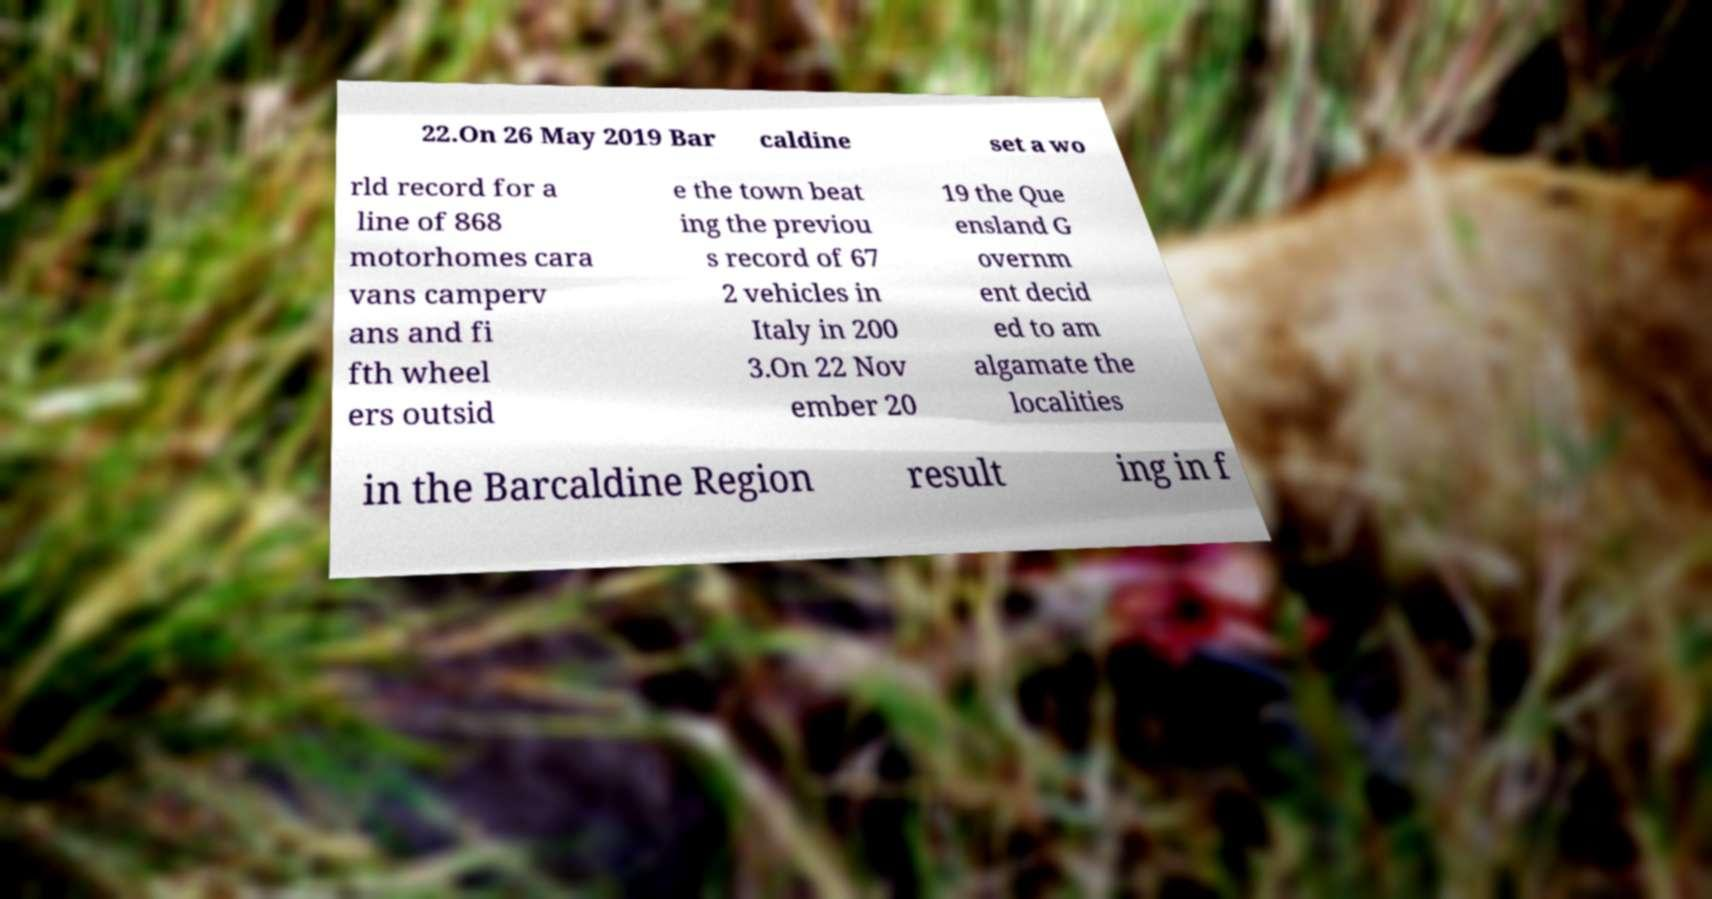Please read and relay the text visible in this image. What does it say? 22.On 26 May 2019 Bar caldine set a wo rld record for a line of 868 motorhomes cara vans camperv ans and fi fth wheel ers outsid e the town beat ing the previou s record of 67 2 vehicles in Italy in 200 3.On 22 Nov ember 20 19 the Que ensland G overnm ent decid ed to am algamate the localities in the Barcaldine Region result ing in f 